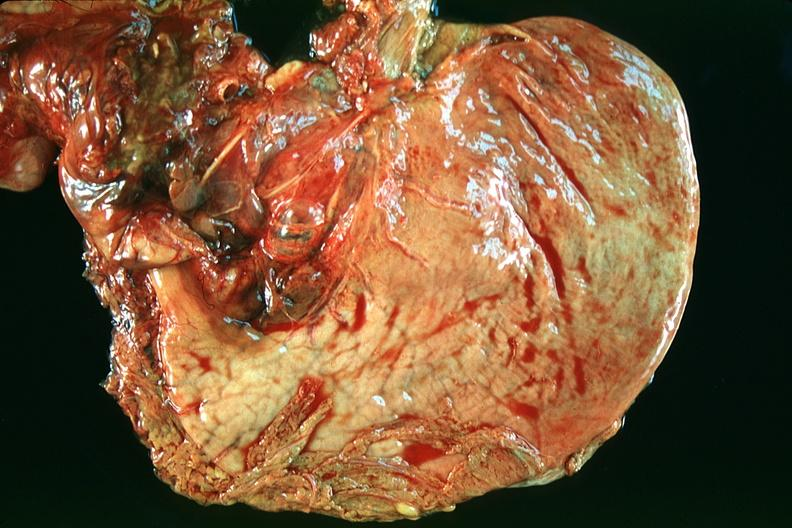s hemochromatosis present?
Answer the question using a single word or phrase. No 